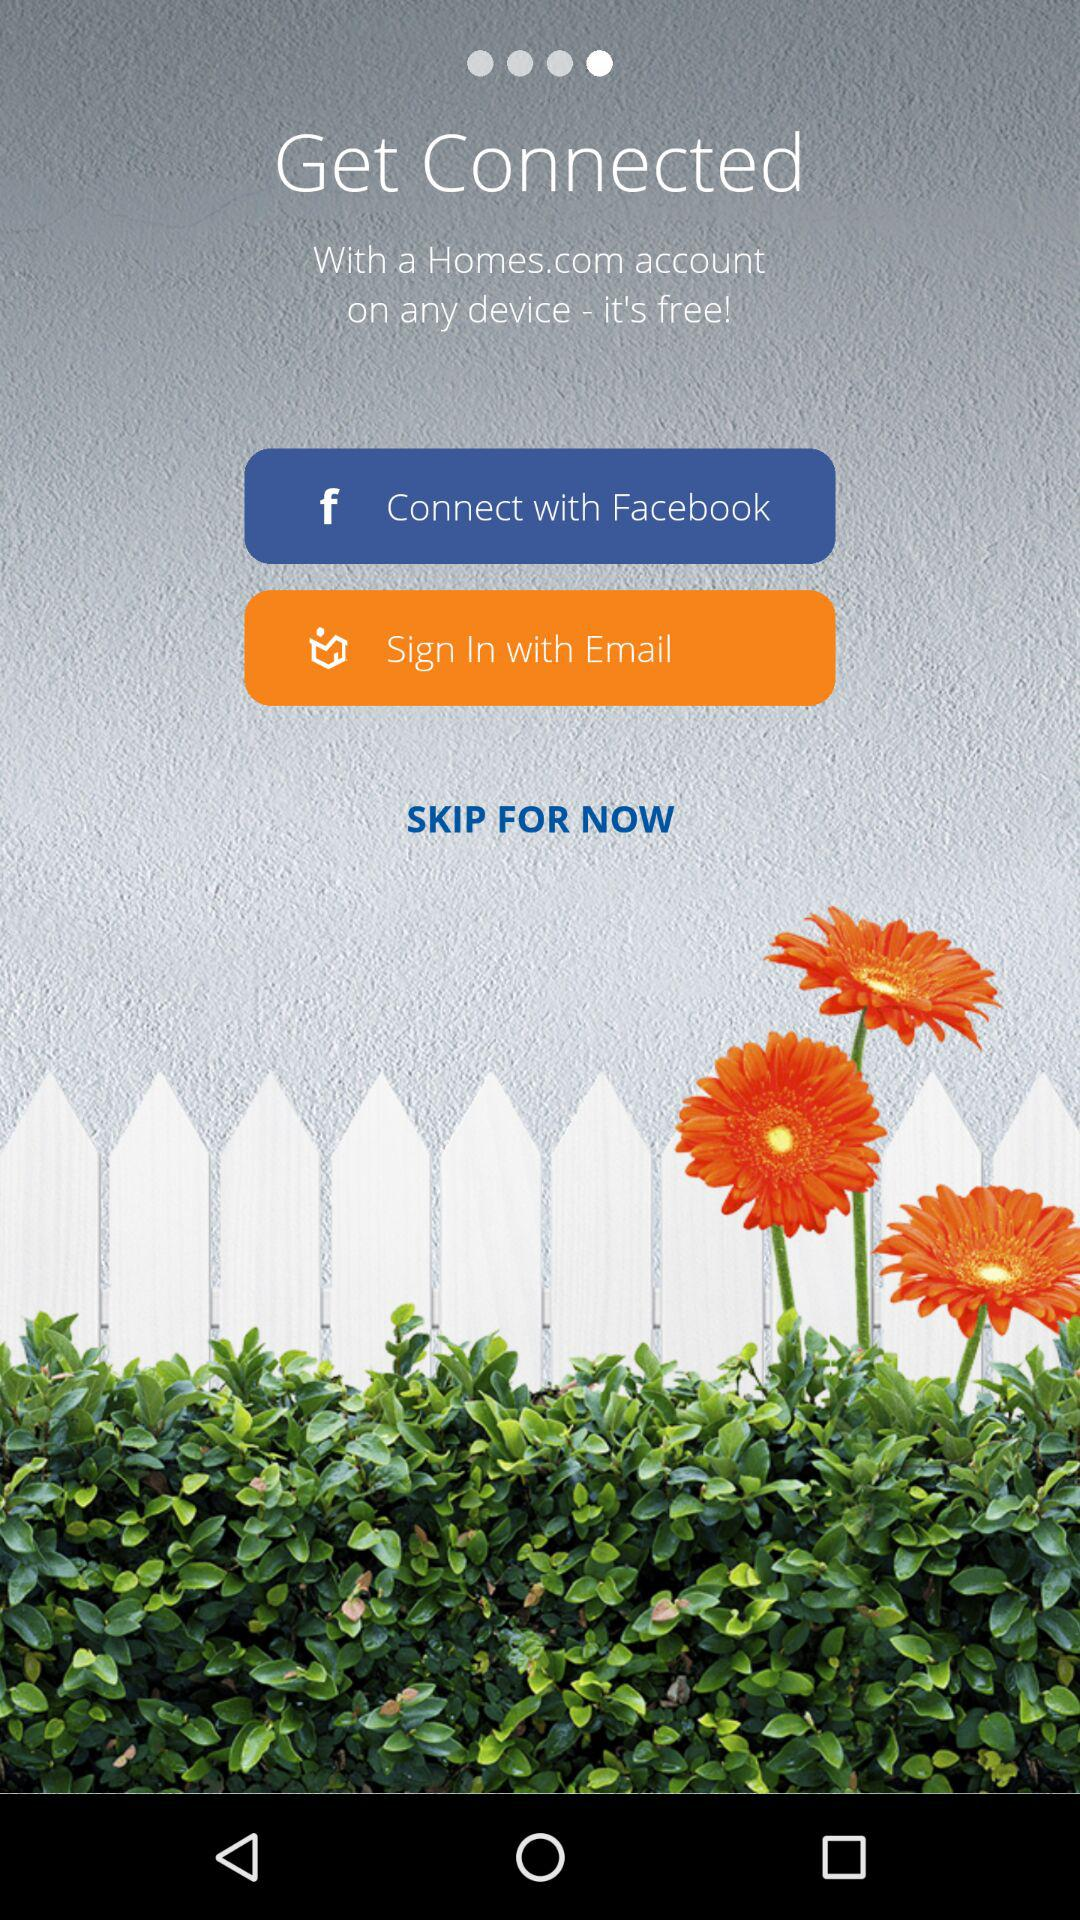With which account can we connect? You can connect with "Facebook" and "Email". 